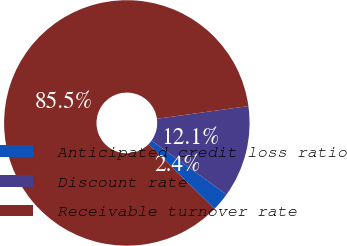Convert chart. <chart><loc_0><loc_0><loc_500><loc_500><pie_chart><fcel>Anticipated credit loss ratio<fcel>Discount rate<fcel>Receivable turnover rate<nl><fcel>2.42%<fcel>12.1%<fcel>85.48%<nl></chart> 